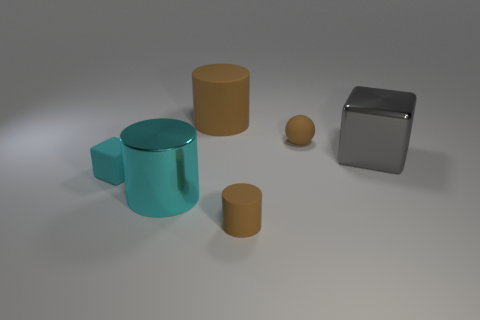How many tiny objects are red spheres or brown things?
Make the answer very short. 2. The small cube that is made of the same material as the brown sphere is what color?
Keep it short and to the point. Cyan. What color is the matte cylinder behind the cyan shiny cylinder?
Make the answer very short. Brown. How many matte objects are the same color as the sphere?
Your answer should be compact. 2. Is the number of cylinders that are to the left of the large brown thing less than the number of matte things right of the rubber block?
Your answer should be very brief. Yes. There is a brown matte sphere; how many brown matte cylinders are to the left of it?
Offer a terse response. 2. Are there any brown balls made of the same material as the cyan block?
Provide a succinct answer. Yes. Are there more tiny rubber things in front of the big gray block than cylinders that are behind the large brown matte cylinder?
Provide a succinct answer. Yes. What is the size of the cyan rubber cube?
Provide a short and direct response. Small. There is a shiny thing that is to the right of the metallic cylinder; what shape is it?
Give a very brief answer. Cube. 